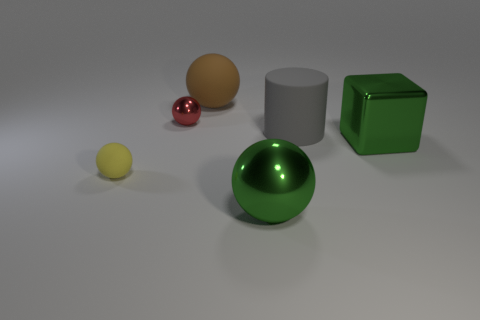Add 3 yellow rubber spheres. How many objects exist? 9 Subtract all tiny yellow rubber spheres. How many spheres are left? 3 Subtract all blue spheres. Subtract all purple cubes. How many spheres are left? 4 Subtract all yellow spheres. How many spheres are left? 3 Subtract 3 balls. How many balls are left? 1 Subtract all blue cylinders. How many blue blocks are left? 0 Subtract all large gray things. Subtract all tiny red spheres. How many objects are left? 4 Add 4 large metallic balls. How many large metallic balls are left? 5 Add 6 big cyan balls. How many big cyan balls exist? 6 Subtract 0 cyan cubes. How many objects are left? 6 